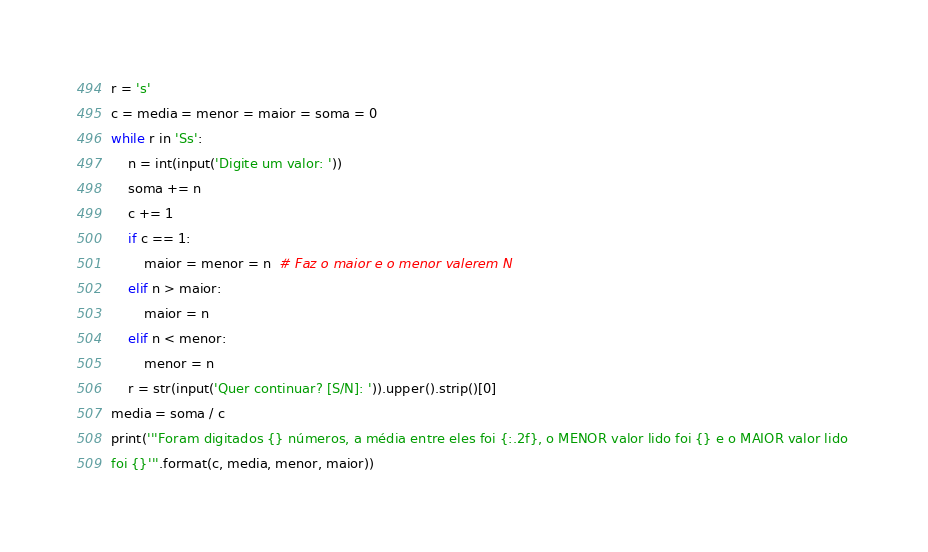Convert code to text. <code><loc_0><loc_0><loc_500><loc_500><_Python_>r = 's'
c = media = menor = maior = soma = 0
while r in 'Ss':
    n = int(input('Digite um valor: '))
    soma += n
    c += 1
    if c == 1:
        maior = menor = n  # Faz o maior e o menor valerem N
    elif n > maior:
        maior = n
    elif n < menor:
        menor = n
    r = str(input('Quer continuar? [S/N]: ')).upper().strip()[0]
media = soma / c
print('''Foram digitados {} números, a média entre eles foi {:.2f}, o MENOR valor lido foi {} e o MAIOR valor lido 
foi {}'''.format(c, media, menor, maior))
</code> 